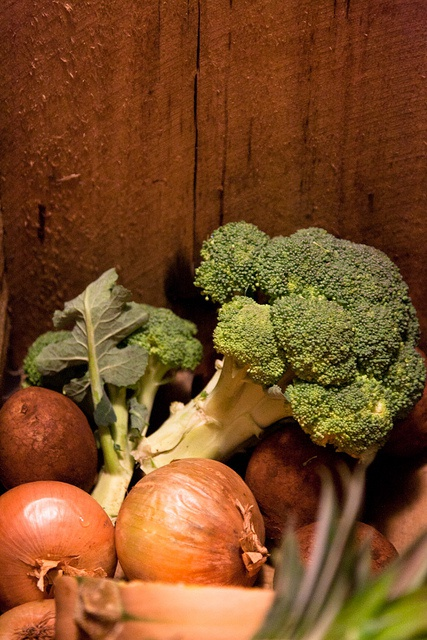Describe the objects in this image and their specific colors. I can see broccoli in maroon, olive, and black tones and broccoli in maroon, olive, and black tones in this image. 